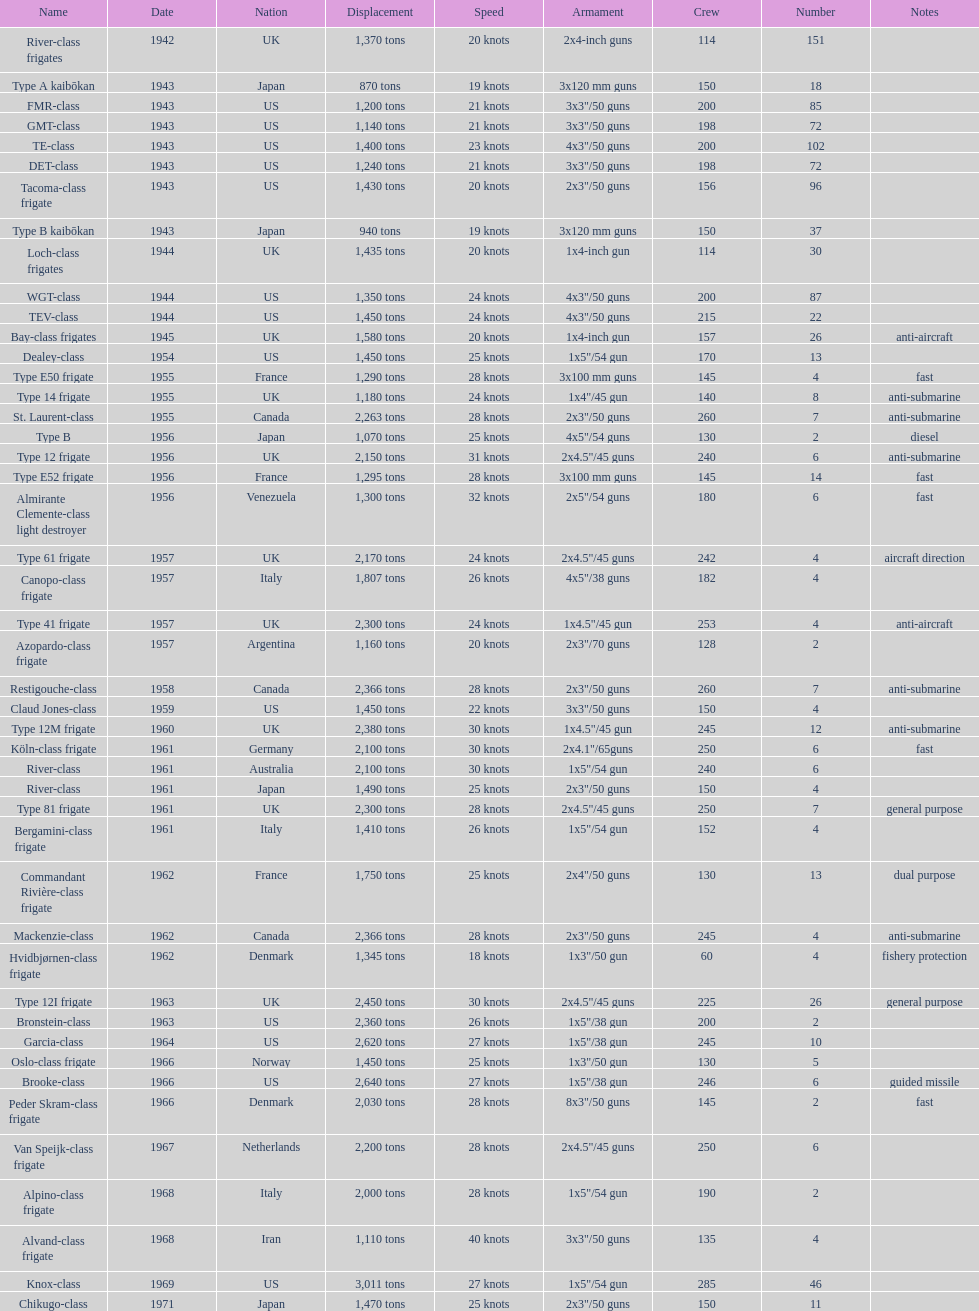In 1968, italy employed the alpino-class frigate - what was its highest achievable speed? 28 knots. Would you mind parsing the complete table? {'header': ['Name', 'Date', 'Nation', 'Displacement', 'Speed', 'Armament', 'Crew', 'Number', 'Notes'], 'rows': [['River-class frigates', '1942', 'UK', '1,370 tons', '20 knots', '2x4-inch guns', '114', '151', ''], ['Type A kaibōkan', '1943', 'Japan', '870 tons', '19 knots', '3x120 mm guns', '150', '18', ''], ['FMR-class', '1943', 'US', '1,200 tons', '21 knots', '3x3"/50 guns', '200', '85', ''], ['GMT-class', '1943', 'US', '1,140 tons', '21 knots', '3x3"/50 guns', '198', '72', ''], ['TE-class', '1943', 'US', '1,400 tons', '23 knots', '4x3"/50 guns', '200', '102', ''], ['DET-class', '1943', 'US', '1,240 tons', '21 knots', '3x3"/50 guns', '198', '72', ''], ['Tacoma-class frigate', '1943', 'US', '1,430 tons', '20 knots', '2x3"/50 guns', '156', '96', ''], ['Type B kaibōkan', '1943', 'Japan', '940 tons', '19 knots', '3x120 mm guns', '150', '37', ''], ['Loch-class frigates', '1944', 'UK', '1,435 tons', '20 knots', '1x4-inch gun', '114', '30', ''], ['WGT-class', '1944', 'US', '1,350 tons', '24 knots', '4x3"/50 guns', '200', '87', ''], ['TEV-class', '1944', 'US', '1,450 tons', '24 knots', '4x3"/50 guns', '215', '22', ''], ['Bay-class frigates', '1945', 'UK', '1,580 tons', '20 knots', '1x4-inch gun', '157', '26', 'anti-aircraft'], ['Dealey-class', '1954', 'US', '1,450 tons', '25 knots', '1x5"/54 gun', '170', '13', ''], ['Type E50 frigate', '1955', 'France', '1,290 tons', '28 knots', '3x100 mm guns', '145', '4', 'fast'], ['Type 14 frigate', '1955', 'UK', '1,180 tons', '24 knots', '1x4"/45 gun', '140', '8', 'anti-submarine'], ['St. Laurent-class', '1955', 'Canada', '2,263 tons', '28 knots', '2x3"/50 guns', '260', '7', 'anti-submarine'], ['Type B', '1956', 'Japan', '1,070 tons', '25 knots', '4x5"/54 guns', '130', '2', 'diesel'], ['Type 12 frigate', '1956', 'UK', '2,150 tons', '31 knots', '2x4.5"/45 guns', '240', '6', 'anti-submarine'], ['Type E52 frigate', '1956', 'France', '1,295 tons', '28 knots', '3x100 mm guns', '145', '14', 'fast'], ['Almirante Clemente-class light destroyer', '1956', 'Venezuela', '1,300 tons', '32 knots', '2x5"/54 guns', '180', '6', 'fast'], ['Type 61 frigate', '1957', 'UK', '2,170 tons', '24 knots', '2x4.5"/45 guns', '242', '4', 'aircraft direction'], ['Canopo-class frigate', '1957', 'Italy', '1,807 tons', '26 knots', '4x5"/38 guns', '182', '4', ''], ['Type 41 frigate', '1957', 'UK', '2,300 tons', '24 knots', '1x4.5"/45 gun', '253', '4', 'anti-aircraft'], ['Azopardo-class frigate', '1957', 'Argentina', '1,160 tons', '20 knots', '2x3"/70 guns', '128', '2', ''], ['Restigouche-class', '1958', 'Canada', '2,366 tons', '28 knots', '2x3"/50 guns', '260', '7', 'anti-submarine'], ['Claud Jones-class', '1959', 'US', '1,450 tons', '22 knots', '3x3"/50 guns', '150', '4', ''], ['Type 12M frigate', '1960', 'UK', '2,380 tons', '30 knots', '1x4.5"/45 gun', '245', '12', 'anti-submarine'], ['Köln-class frigate', '1961', 'Germany', '2,100 tons', '30 knots', '2x4.1"/65guns', '250', '6', 'fast'], ['River-class', '1961', 'Australia', '2,100 tons', '30 knots', '1x5"/54 gun', '240', '6', ''], ['River-class', '1961', 'Japan', '1,490 tons', '25 knots', '2x3"/50 guns', '150', '4', ''], ['Type 81 frigate', '1961', 'UK', '2,300 tons', '28 knots', '2x4.5"/45 guns', '250', '7', 'general purpose'], ['Bergamini-class frigate', '1961', 'Italy', '1,410 tons', '26 knots', '1x5"/54 gun', '152', '4', ''], ['Commandant Rivière-class frigate', '1962', 'France', '1,750 tons', '25 knots', '2x4"/50 guns', '130', '13', 'dual purpose'], ['Mackenzie-class', '1962', 'Canada', '2,366 tons', '28 knots', '2x3"/50 guns', '245', '4', 'anti-submarine'], ['Hvidbjørnen-class frigate', '1962', 'Denmark', '1,345 tons', '18 knots', '1x3"/50 gun', '60', '4', 'fishery protection'], ['Type 12I frigate', '1963', 'UK', '2,450 tons', '30 knots', '2x4.5"/45 guns', '225', '26', 'general purpose'], ['Bronstein-class', '1963', 'US', '2,360 tons', '26 knots', '1x5"/38 gun', '200', '2', ''], ['Garcia-class', '1964', 'US', '2,620 tons', '27 knots', '1x5"/38 gun', '245', '10', ''], ['Oslo-class frigate', '1966', 'Norway', '1,450 tons', '25 knots', '1x3"/50 gun', '130', '5', ''], ['Brooke-class', '1966', 'US', '2,640 tons', '27 knots', '1x5"/38 gun', '246', '6', 'guided missile'], ['Peder Skram-class frigate', '1966', 'Denmark', '2,030 tons', '28 knots', '8x3"/50 guns', '145', '2', 'fast'], ['Van Speijk-class frigate', '1967', 'Netherlands', '2,200 tons', '28 knots', '2x4.5"/45 guns', '250', '6', ''], ['Alpino-class frigate', '1968', 'Italy', '2,000 tons', '28 knots', '1x5"/54 gun', '190', '2', ''], ['Alvand-class frigate', '1968', 'Iran', '1,110 tons', '40 knots', '3x3"/50 guns', '135', '4', ''], ['Knox-class', '1969', 'US', '3,011 tons', '27 knots', '1x5"/54 gun', '285', '46', ''], ['Chikugo-class', '1971', 'Japan', '1,470 tons', '25 knots', '2x3"/50 guns', '150', '11', '']]} 